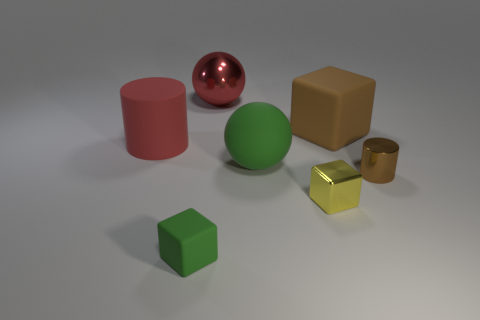There is a thing that is the same color as the tiny cylinder; what is its shape?
Your answer should be very brief. Cube. What size is the matte block that is on the right side of the red ball?
Offer a terse response. Large. There is a red object that is the same material as the green block; what is its shape?
Offer a terse response. Cylinder. Do the red sphere and the big red object that is in front of the brown cube have the same material?
Provide a short and direct response. No. Is the shape of the green matte thing on the right side of the large shiny object the same as  the yellow metallic object?
Your answer should be compact. No. There is a tiny brown thing that is the same shape as the big red matte object; what is its material?
Provide a short and direct response. Metal. There is a large red metal thing; is its shape the same as the brown thing that is behind the tiny brown shiny cylinder?
Your answer should be very brief. No. There is a shiny object that is in front of the brown rubber cube and behind the small metal cube; what is its color?
Provide a short and direct response. Brown. Are any big shiny balls visible?
Give a very brief answer. Yes. Are there the same number of metal things in front of the brown cylinder and tiny shiny spheres?
Ensure brevity in your answer.  No. 